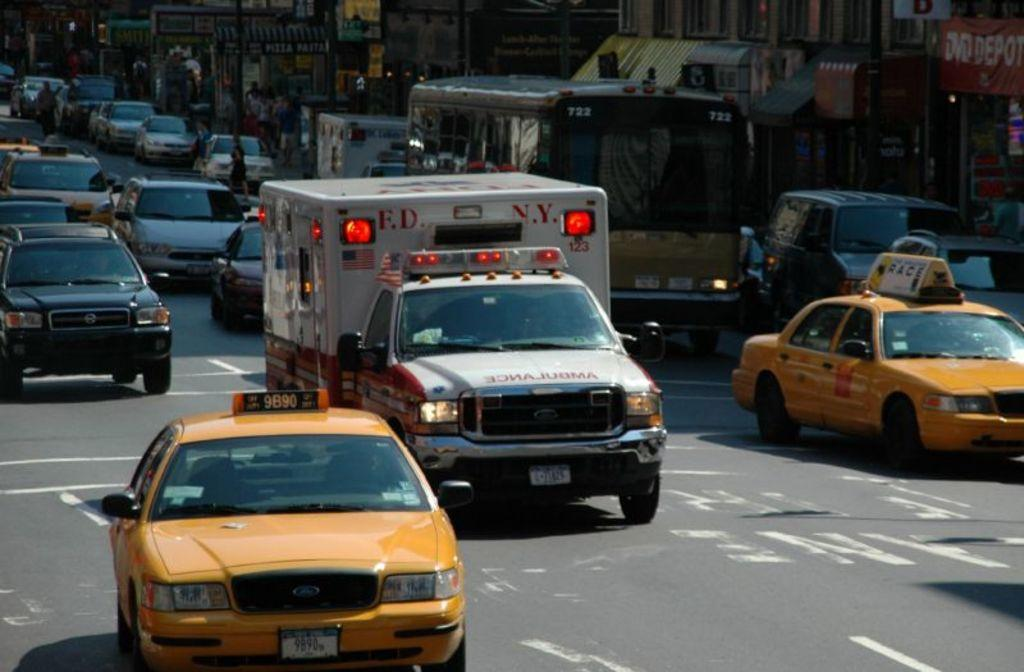Provide a one-sentence caption for the provided image. An ambulance, from the F.D.N.Y., is going through traffic. 